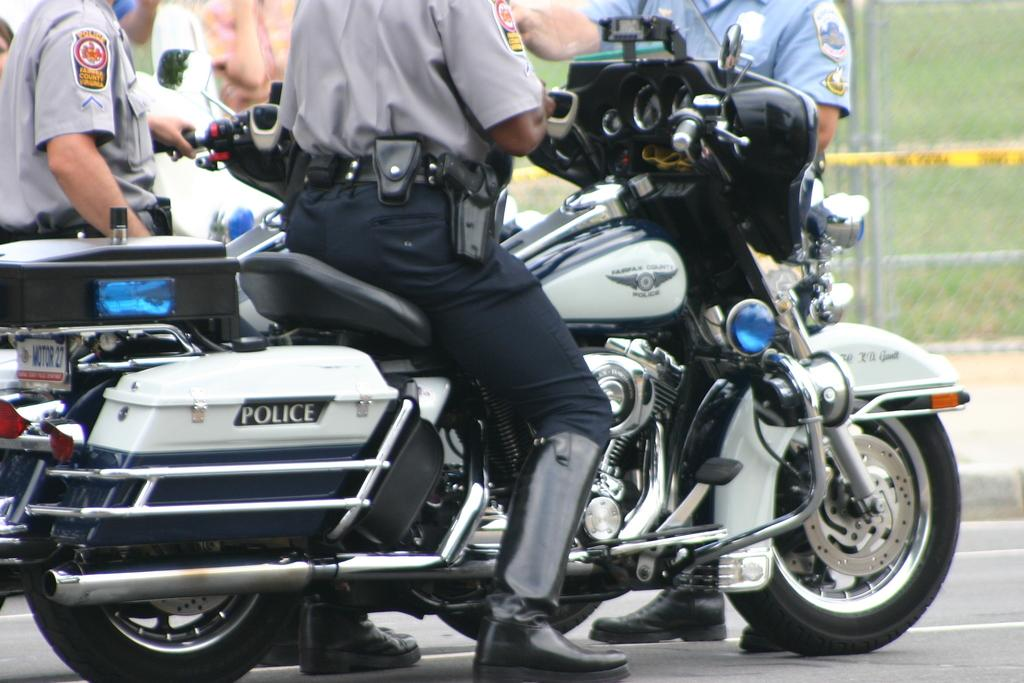What are the two people in the image doing? The two people are sitting on motorbikes. What are the other people in the image doing? Some people are standing on the road. What can be seen in the background of the image? There is a fence and grass in the background of the image. What language are the people speaking in the image? The image does not provide any information about the language being spoken by the people. Is there a sink visible in the image? There is no sink present in the image. 